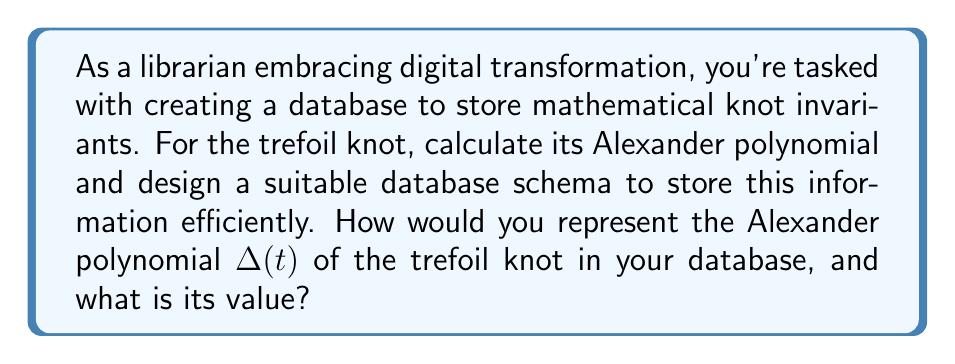Could you help me with this problem? To solve this problem, we'll follow these steps:

1) First, let's calculate the Alexander polynomial for the trefoil knot:

   a) The trefoil knot can be represented by the braid word $\sigma_1^3$.
   
   b) From this, we can construct the Burau matrix:
      $$B = \begin{pmatrix} 
      1-t & t & 0 \\
      0 & 1 & 0 \\
      0 & 0 & 1
      \end{pmatrix}^3$$

   c) Calculating this, we get:
      $$B = \begin{pmatrix} 
      1-t+t^2 & t-t^2 & t^2 \\
      -t & 1 & 0 \\
      -t & 0 & 1
      \end{pmatrix}$$

   d) The Alexander polynomial is then given by:
      $$\Delta(t) = \det(I - B) = \det\begin{pmatrix} 
      t-t^2 & -t+t^2 & -t^2 \\
      t & 0 & 0 \\
      t & 0 & 0
      \end{pmatrix}$$

   e) Calculating this determinant:
      $$\Delta(t) = (t-t^2)(0) - (-t+t^2)(t) = t - t^2 + t^3 = t(1-t+t^2)$$

2) To store this in a database efficiently:

   a) Create a table named 'KnotInvariants' with columns:
      - KnotID (primary key)
      - KnotName
      - AlexanderPolynomial
      - Coefficients (as an array or JSON)

   b) For the trefoil knot, you would store:
      - KnotID: 1
      - KnotName: "Trefoil"
      - AlexanderPolynomial: "t(1-t+t^2)"
      - Coefficients: [1, -1, 1] (representing 1*t^1 + (-1)*t^2 + 1*t^3)

This structure allows for efficient storage and retrieval of the polynomial, both in its symbolic form and as a list of coefficients for computational purposes.
Answer: $t(1-t+t^2)$; [1, -1, 1] 